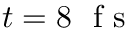Convert formula to latex. <formula><loc_0><loc_0><loc_500><loc_500>t = 8 f s</formula> 